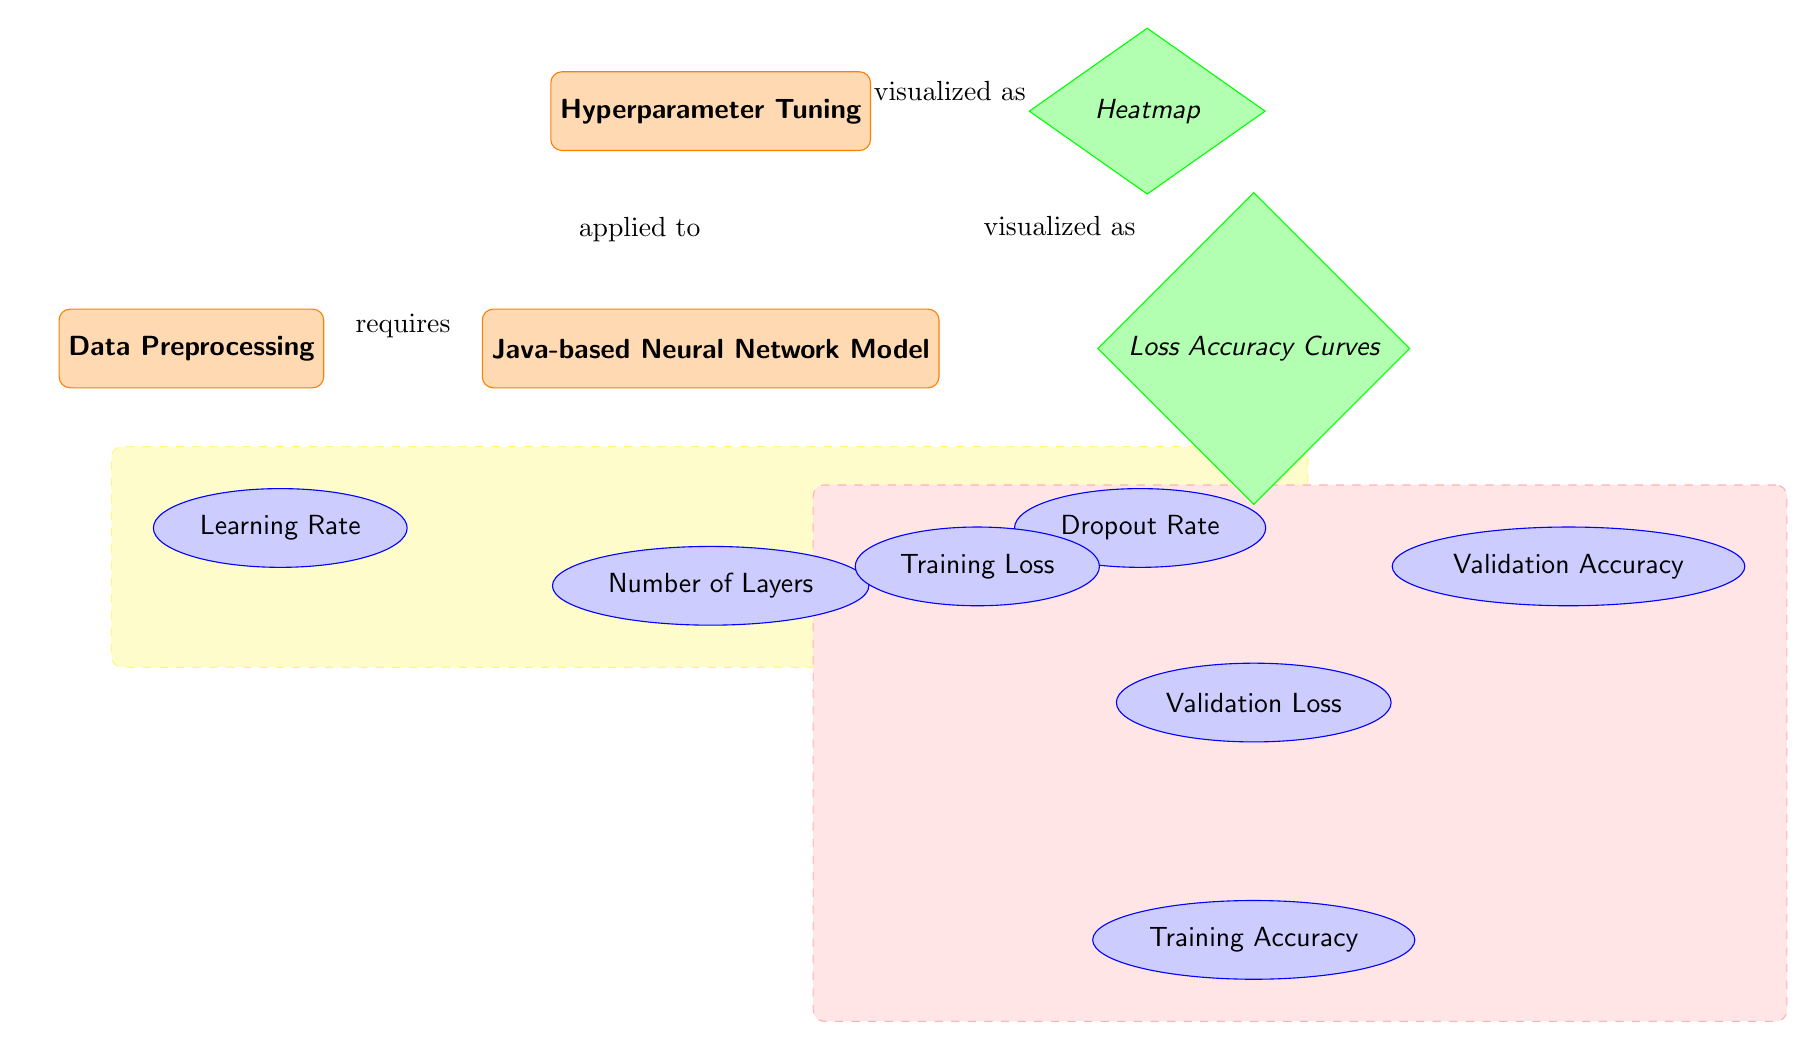What's the main process depicted in the diagram? The diagram primarily illustrates the process of hyperparameter tuning for a neural network model built in Java, as indicated by the node labeled "Hyperparameter Tuning."
Answer: Hyperparameter Tuning How many parameters are listed under the Java-based Neural Network Model? There are three parameters mentioned: Learning Rate, Number of Layers, and Dropout Rate, all branching from the Java-based Neural Network Model node.
Answer: Three What type of visualizations are used in the diagram? The diagram includes two types of visualizations: a Heatmap and Loss Accuracy Curves, represented by the diamonds labeled as such.
Answer: Heatmap and Loss Accuracy Curves Which process requires data preprocessing? The node labeled "Java-based Neural Network Model" shows an arrow indicating that it requires data preprocessing, as depicted in the diagram.
Answer: Java-based Neural Network Model What relationship exists between hyperparameter tuning and the generated loss accuracy curves? The arrow from the "Hyperparameter Tuning" node to the "Loss Accuracy Curves" node indicates that the tuning process results in these curves, hence establishing a directional relationship.
Answer: Visualized as What specific data is obtained from the loss accuracy curves? The data comprises Training Loss, Validation Loss, Training Accuracy, and Validation Accuracy, which are all depicted as outputs stemming from the Loss Accuracy Curves node.
Answer: Training Loss, Validation Loss, Training Accuracy, and Validation Accuracy Which hyperparameters are visualized in the heatmap? The heatmap visualizes the parameters Learning Rate, Number of Layers, and Dropout Rate, as shown by the arrows leading from the heatmap to each parameter.
Answer: Learning Rate, Number of Layers, Dropout Rate What shape are the nodes representing visualizations in the diagram? The visualizations are represented by diamond-shaped nodes, which is characteristic of this diagram's layout.
Answer: Diamond 